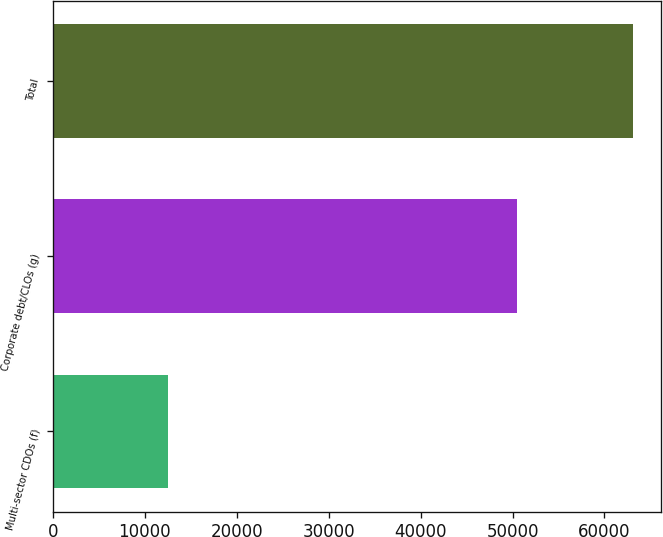<chart> <loc_0><loc_0><loc_500><loc_500><bar_chart><fcel>Multi-sector CDOs (f)<fcel>Corporate debt/CLOs (g)<fcel>Total<nl><fcel>12556<fcel>50495<fcel>63051<nl></chart> 